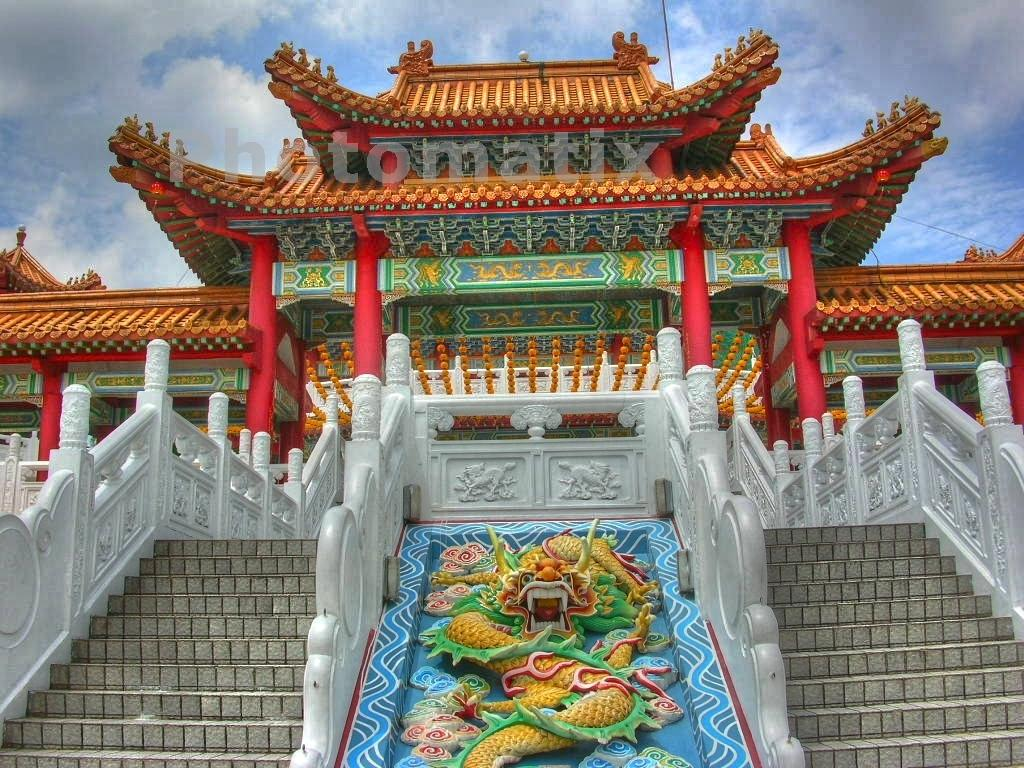What type of structure is present in the picture? There is a building in the picture. Are there any architectural features visible in the image? Yes, there are stairs in the picture. the picture. How would you describe the weather based on the sky in the image? The sky is blue and cloudy. Can you identify any additional elements in the picture that might not be part of the main subject? Yes, there is a watermark at the top of the picture. What type of apparatus is being used by the building to generate electricity in the image? There is no apparatus for generating electricity visible in the image; it only shows a building and stairs. What is the front of the building made of in the image? The provided facts do not mention the material of the building's front, so we cannot determine that information from the image. 